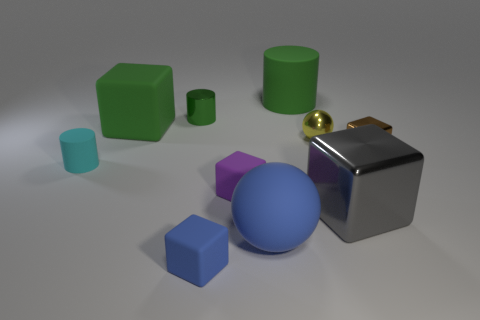Subtract all brown blocks. How many blocks are left? 4 Subtract all brown blocks. How many blocks are left? 4 Subtract 1 cubes. How many cubes are left? 4 Subtract all yellow blocks. Subtract all gray balls. How many blocks are left? 5 Subtract all spheres. How many objects are left? 8 Add 7 brown objects. How many brown objects are left? 8 Add 7 cyan objects. How many cyan objects exist? 8 Subtract 1 cyan cylinders. How many objects are left? 9 Subtract all big green cubes. Subtract all cyan objects. How many objects are left? 8 